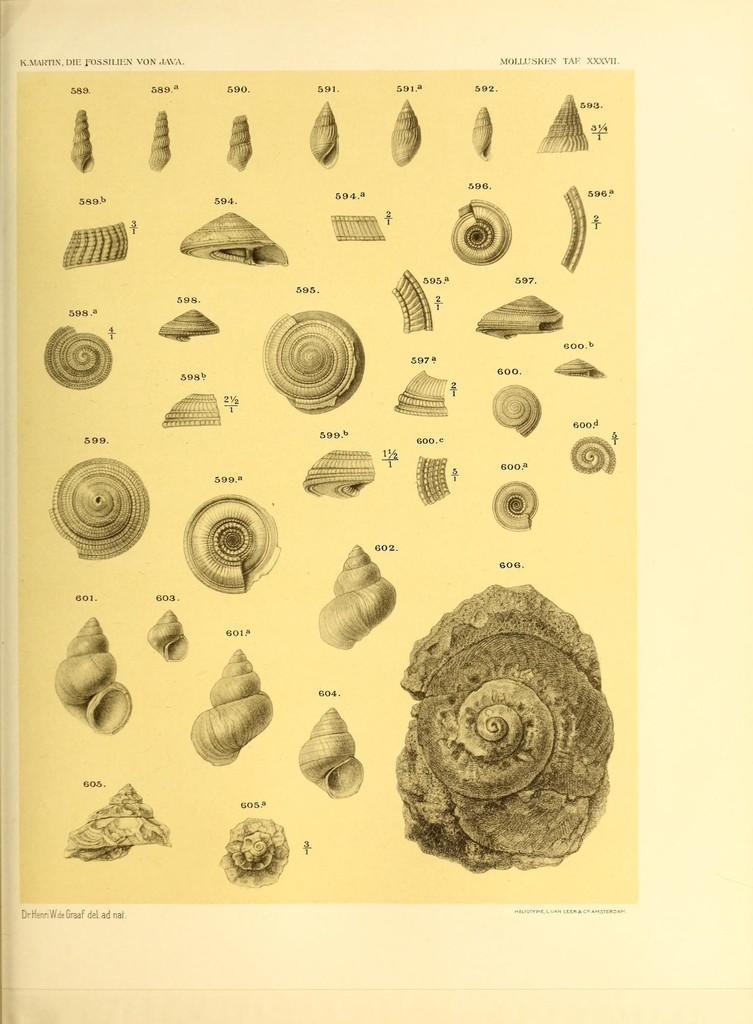What is depicted in the images in the picture? There are pictures of shells in the image. What is the medium on which the images are displayed? The pictures are on a paper. How many sheep are visible in the image? There are no sheep present in the image; it features pictures of shells on a paper. What type of cup is being used to show the shells in the image? There is no cup present in the image; the shells are depicted on a paper. 